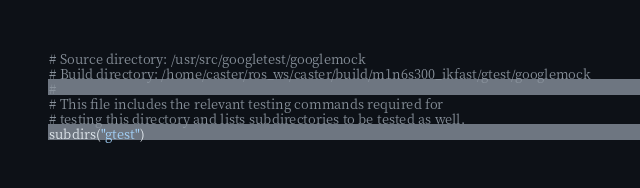<code> <loc_0><loc_0><loc_500><loc_500><_CMake_># Source directory: /usr/src/googletest/googlemock
# Build directory: /home/caster/ros_ws/caster/build/m1n6s300_ikfast/gtest/googlemock
# 
# This file includes the relevant testing commands required for 
# testing this directory and lists subdirectories to be tested as well.
subdirs("gtest")
</code> 